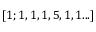Convert formula to latex. <formula><loc_0><loc_0><loc_500><loc_500>[ 1 ; 1 , 1 , 1 , 5 , 1 , 1 \dots ]</formula> 